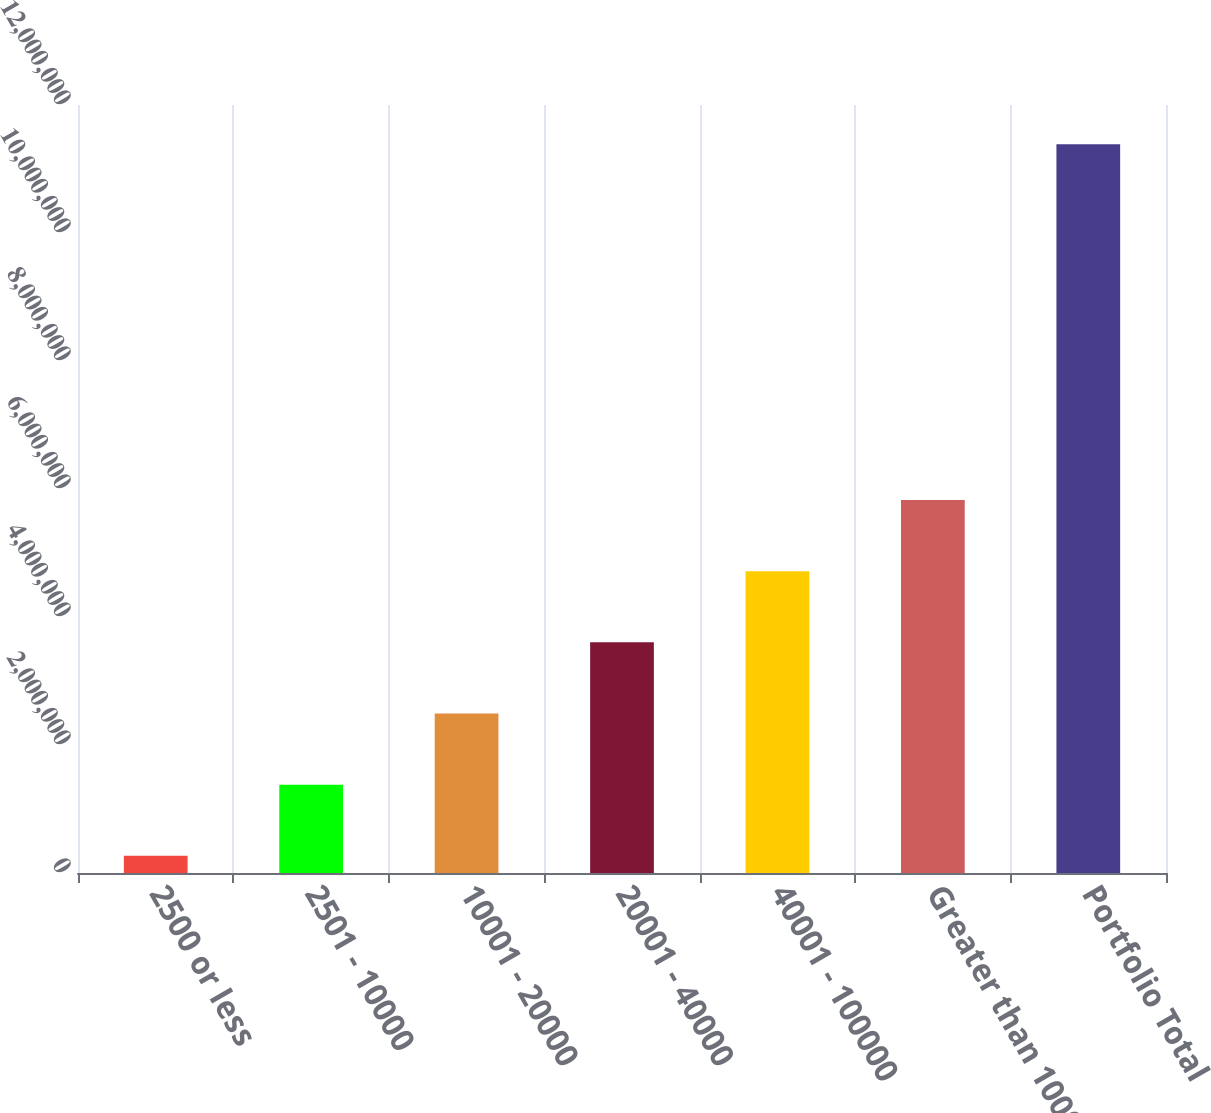Convert chart to OTSL. <chart><loc_0><loc_0><loc_500><loc_500><bar_chart><fcel>2500 or less<fcel>2501 - 10000<fcel>10001 - 20000<fcel>20001 - 40000<fcel>40001 - 100000<fcel>Greater than 100000<fcel>Portfolio Total<nl><fcel>268922<fcel>1.38074e+06<fcel>2.49256e+06<fcel>3.60438e+06<fcel>4.71619e+06<fcel>5.82801e+06<fcel>1.13871e+07<nl></chart> 